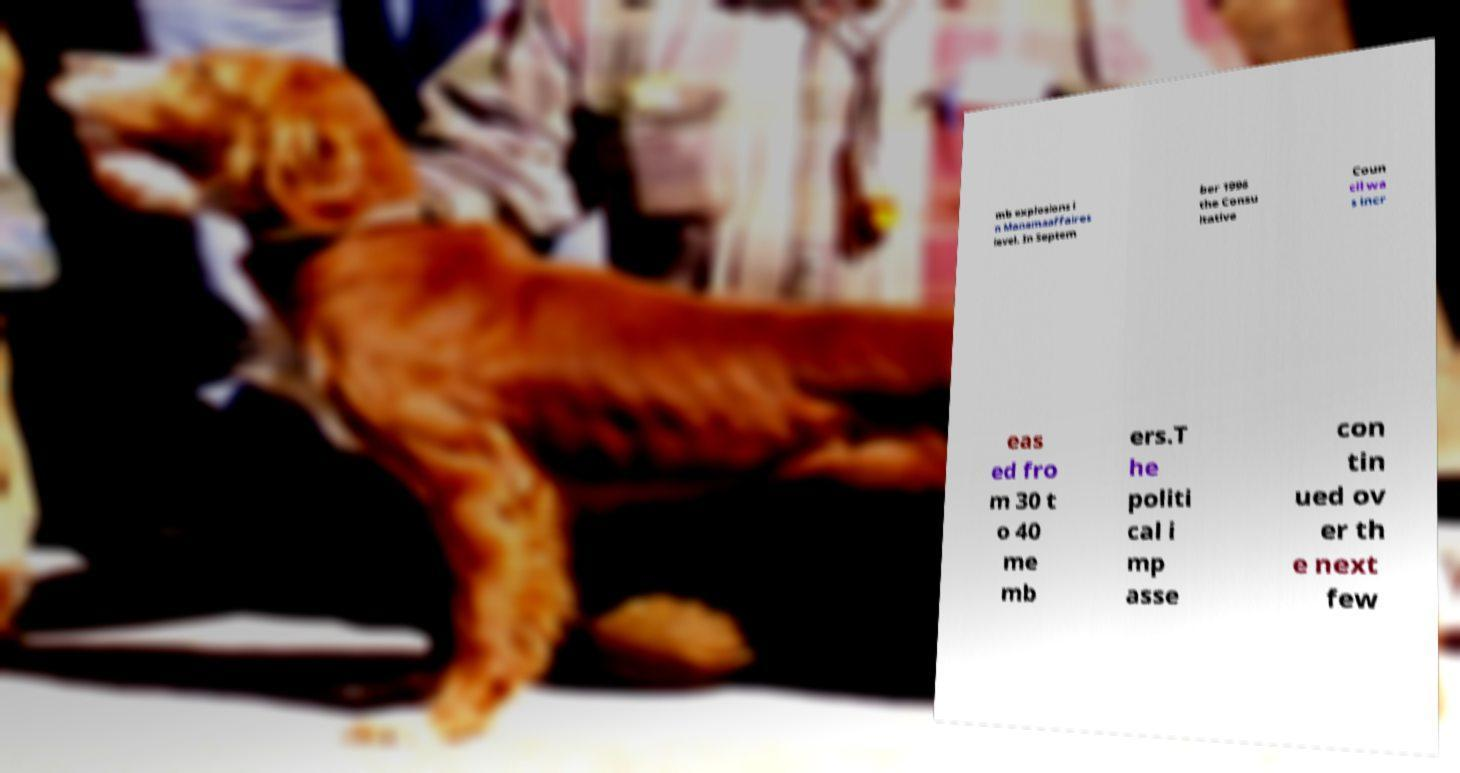Could you assist in decoding the text presented in this image and type it out clearly? mb explosions i n Manamaaffaires level. In Septem ber 1996 the Consu ltative Coun cil wa s incr eas ed fro m 30 t o 40 me mb ers.T he politi cal i mp asse con tin ued ov er th e next few 